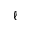Convert formula to latex. <formula><loc_0><loc_0><loc_500><loc_500>\ell</formula> 